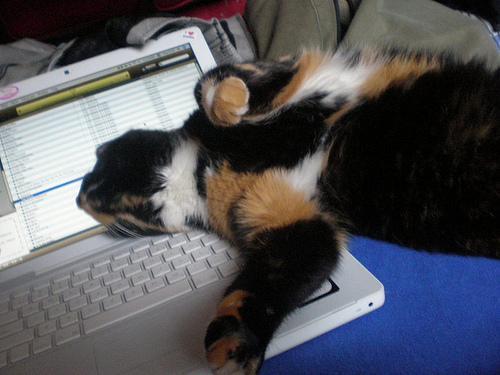How many cats are shown?
Give a very brief answer. 1. 